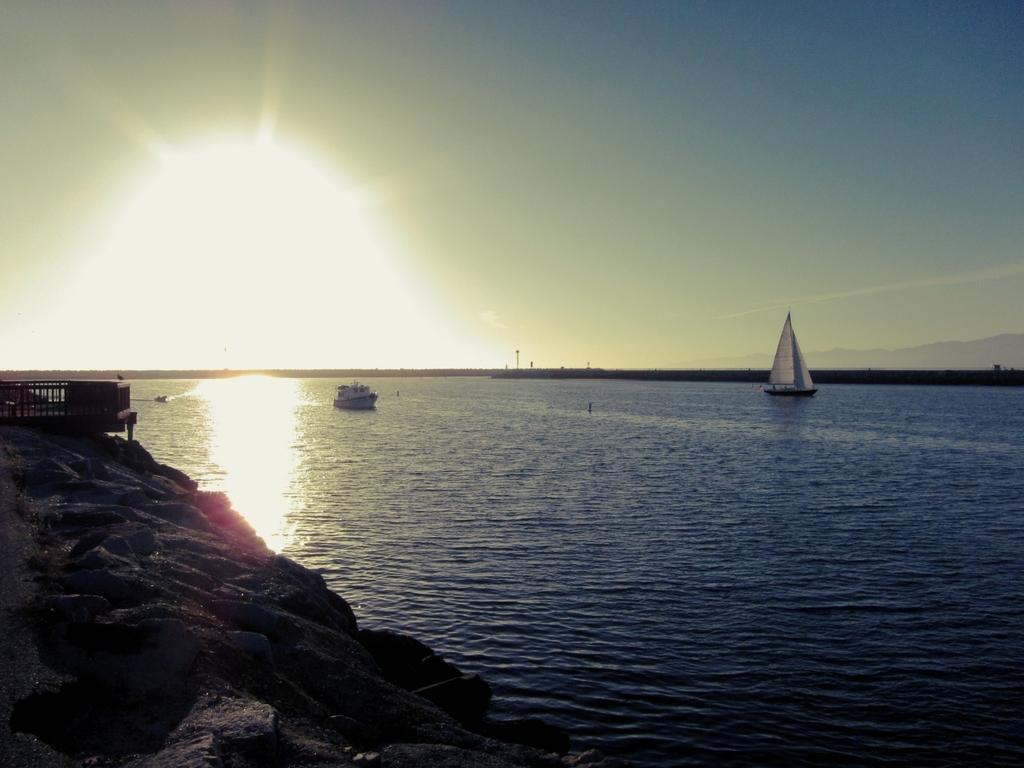Describe this image in one or two sentences. In this image in the center there are boats sailing on the water. On the left side there is a bridge and on the right side there are poles. 